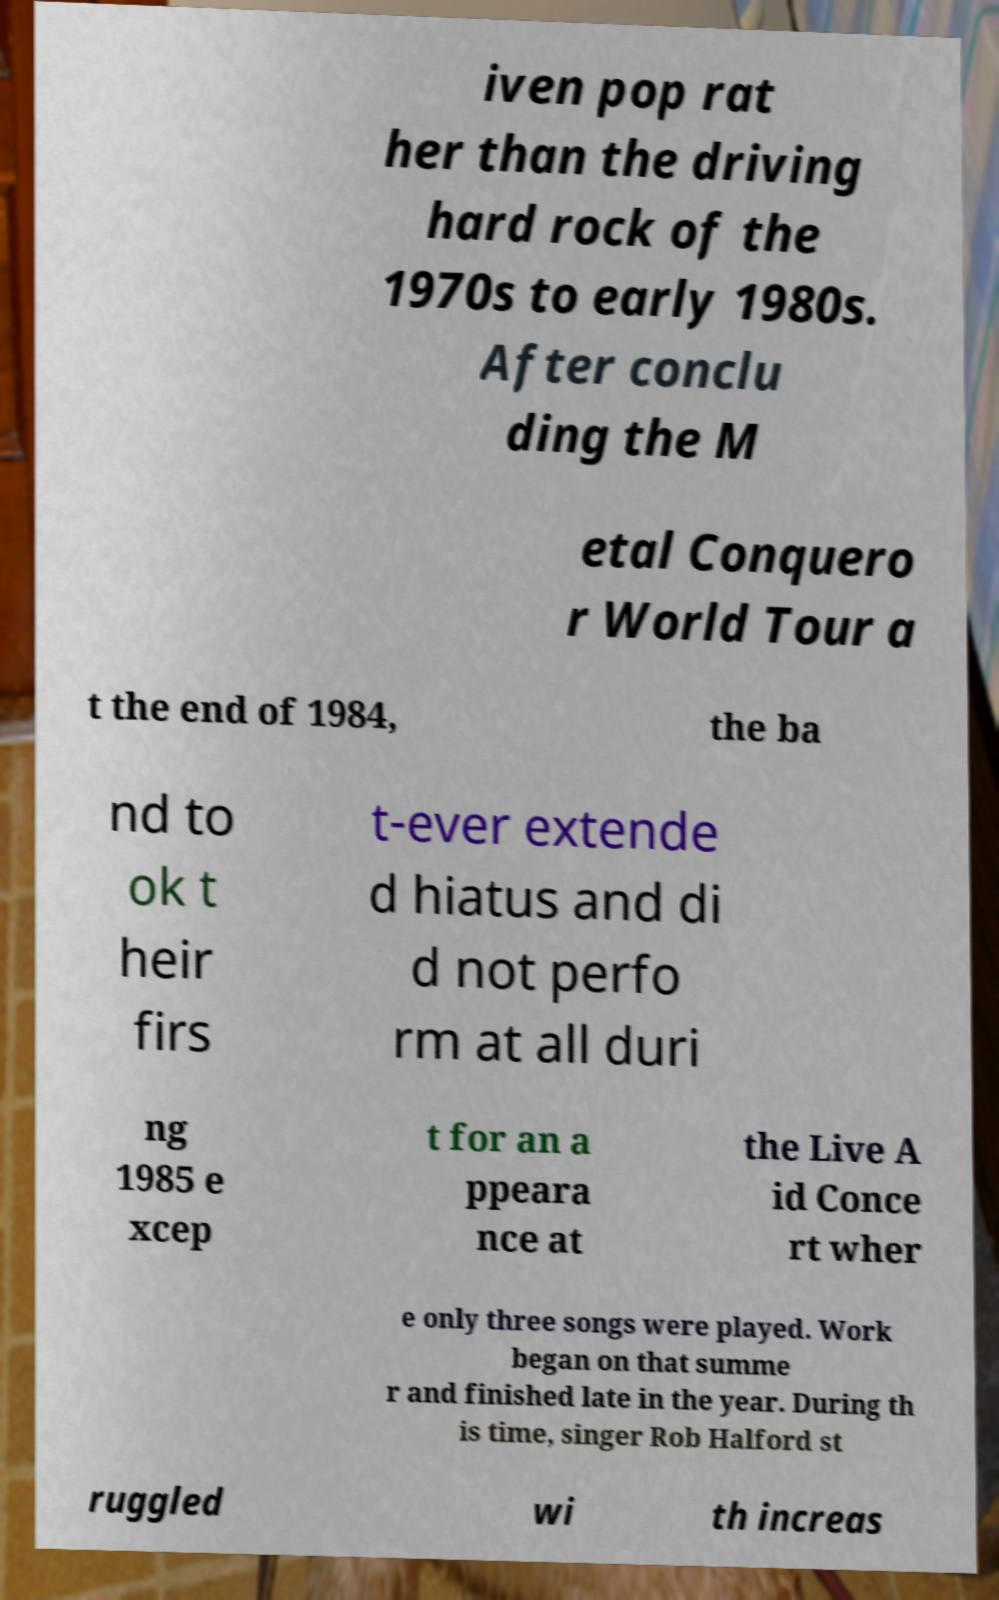Can you accurately transcribe the text from the provided image for me? iven pop rat her than the driving hard rock of the 1970s to early 1980s. After conclu ding the M etal Conquero r World Tour a t the end of 1984, the ba nd to ok t heir firs t-ever extende d hiatus and di d not perfo rm at all duri ng 1985 e xcep t for an a ppeara nce at the Live A id Conce rt wher e only three songs were played. Work began on that summe r and finished late in the year. During th is time, singer Rob Halford st ruggled wi th increas 